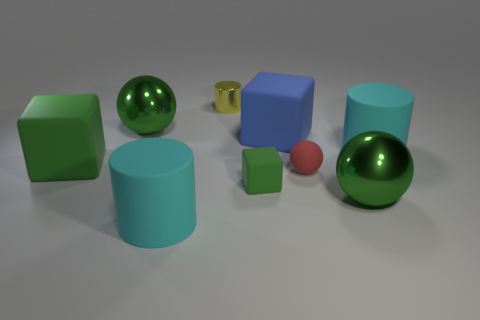Subtract all tiny balls. How many balls are left? 2 Subtract all purple spheres. How many cyan cylinders are left? 2 Subtract 1 cylinders. How many cylinders are left? 2 Add 7 small matte cubes. How many small matte cubes are left? 8 Add 6 big cyan matte things. How many big cyan matte things exist? 8 Subtract 2 green blocks. How many objects are left? 7 Subtract all cylinders. How many objects are left? 6 Subtract all green blocks. Subtract all green cylinders. How many blocks are left? 1 Subtract all green metal objects. Subtract all large blocks. How many objects are left? 5 